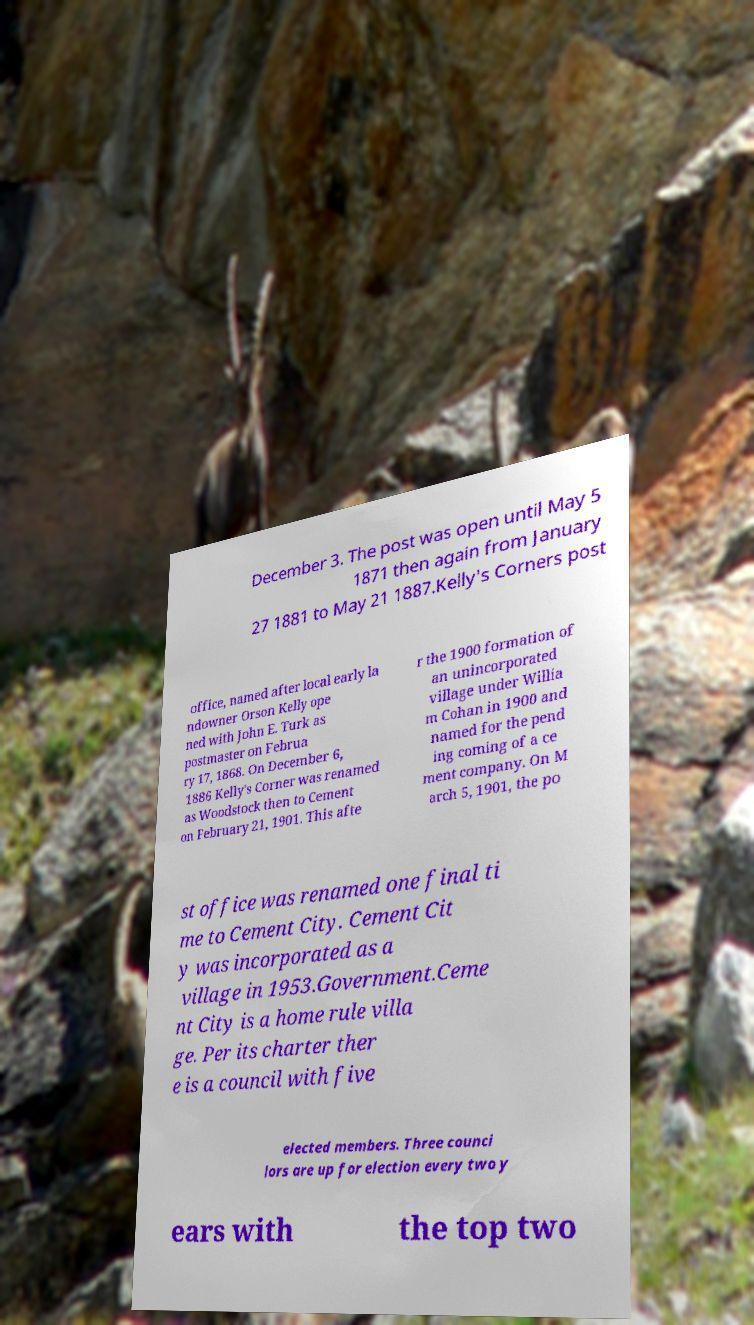For documentation purposes, I need the text within this image transcribed. Could you provide that? December 3. The post was open until May 5 1871 then again from January 27 1881 to May 21 1887.Kelly's Corners post office, named after local early la ndowner Orson Kelly ope ned with John E. Turk as postmaster on Februa ry 17, 1868. On December 6, 1886 Kelly's Corner was renamed as Woodstock then to Cement on February 21, 1901. This afte r the 1900 formation of an unincorporated village under Willia m Cohan in 1900 and named for the pend ing coming of a ce ment company. On M arch 5, 1901, the po st office was renamed one final ti me to Cement City. Cement Cit y was incorporated as a village in 1953.Government.Ceme nt City is a home rule villa ge. Per its charter ther e is a council with five elected members. Three counci lors are up for election every two y ears with the top two 